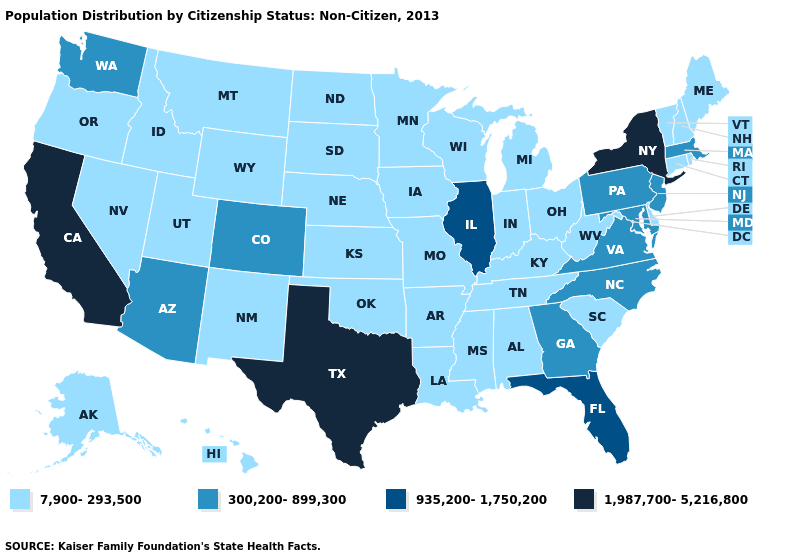Name the states that have a value in the range 935,200-1,750,200?
Give a very brief answer. Florida, Illinois. Among the states that border Iowa , which have the lowest value?
Concise answer only. Minnesota, Missouri, Nebraska, South Dakota, Wisconsin. Does Washington have a lower value than Georgia?
Short answer required. No. Name the states that have a value in the range 1,987,700-5,216,800?
Quick response, please. California, New York, Texas. What is the highest value in states that border Oregon?
Quick response, please. 1,987,700-5,216,800. How many symbols are there in the legend?
Answer briefly. 4. What is the value of South Carolina?
Give a very brief answer. 7,900-293,500. Is the legend a continuous bar?
Give a very brief answer. No. What is the lowest value in the West?
Keep it brief. 7,900-293,500. Which states have the lowest value in the Northeast?
Give a very brief answer. Connecticut, Maine, New Hampshire, Rhode Island, Vermont. Name the states that have a value in the range 1,987,700-5,216,800?
Concise answer only. California, New York, Texas. Does the first symbol in the legend represent the smallest category?
Quick response, please. Yes. Does Minnesota have the highest value in the MidWest?
Concise answer only. No. How many symbols are there in the legend?
Give a very brief answer. 4. Which states have the highest value in the USA?
Be succinct. California, New York, Texas. 